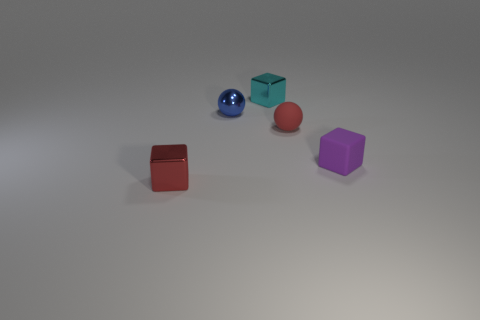Is there any other thing that has the same shape as the small purple object? Yes, the small purple object is cube-shaped, and it shares the same six-sided cubic geometry as the blue object in the image. 